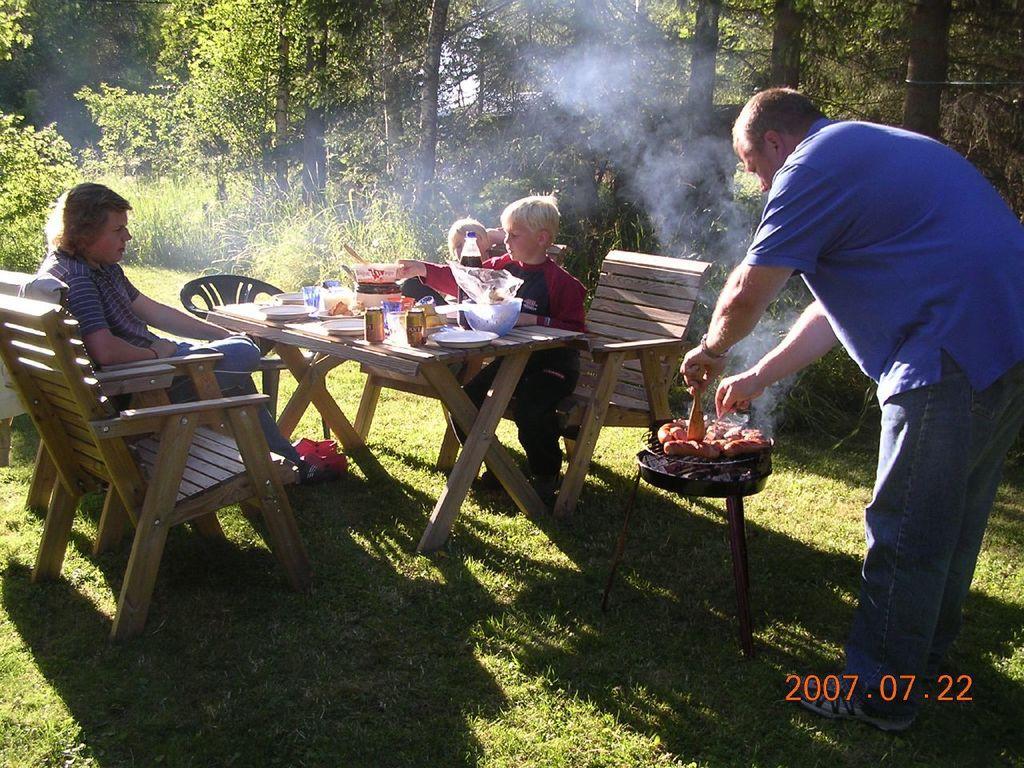Please provide a concise description of this image. In this picture we can see three persons where two are sitting on chair and other is standing and roasting some food item and in front of this two persons there is table and on table we can see tin, plate, bowl, plastic cover, bottle and in the background we can see trees. 